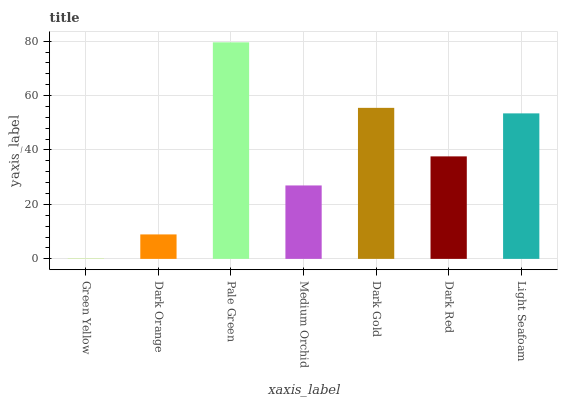Is Dark Orange the minimum?
Answer yes or no. No. Is Dark Orange the maximum?
Answer yes or no. No. Is Dark Orange greater than Green Yellow?
Answer yes or no. Yes. Is Green Yellow less than Dark Orange?
Answer yes or no. Yes. Is Green Yellow greater than Dark Orange?
Answer yes or no. No. Is Dark Orange less than Green Yellow?
Answer yes or no. No. Is Dark Red the high median?
Answer yes or no. Yes. Is Dark Red the low median?
Answer yes or no. Yes. Is Pale Green the high median?
Answer yes or no. No. Is Pale Green the low median?
Answer yes or no. No. 